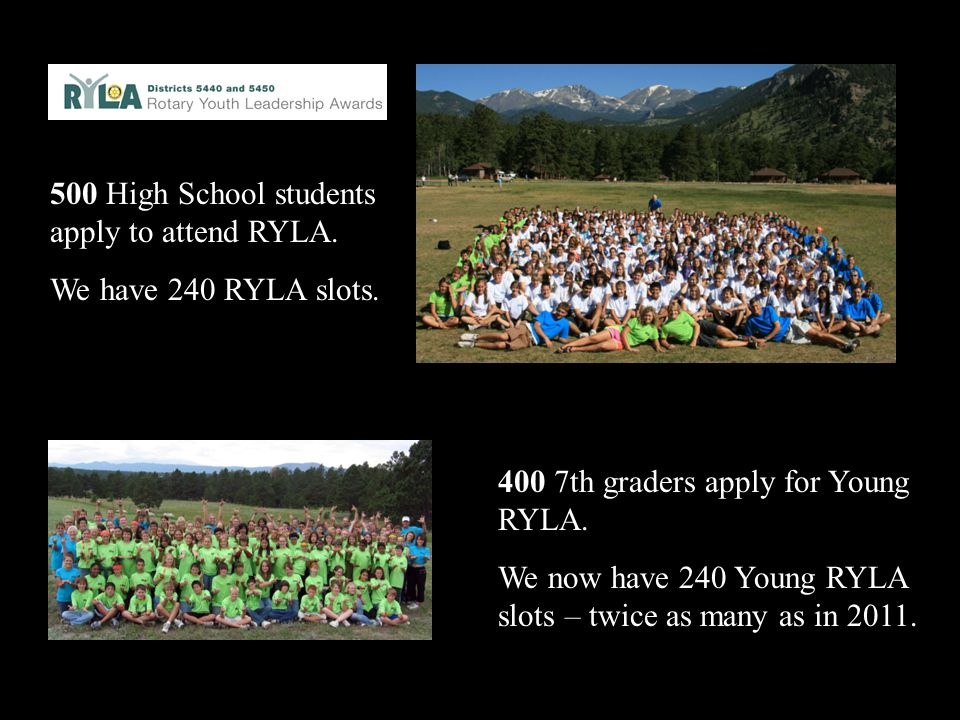What kind of activities do you think these students might be participating in during the camp? During the camp, students are likely participating in a range of activities designed to build leadership skills, teamwork, and personal development. These activities might include outdoor team-building exercises such as obstacle courses, trust falls, and group problem-solving challenges. There could also be workshops and seminars on topics like communication, goal setting, and conflict resolution. Additionally, participants might engage in creative projects, community service initiatives, and social activities to foster bonds and encourage a sense of responsibility and leadership within their communities. 